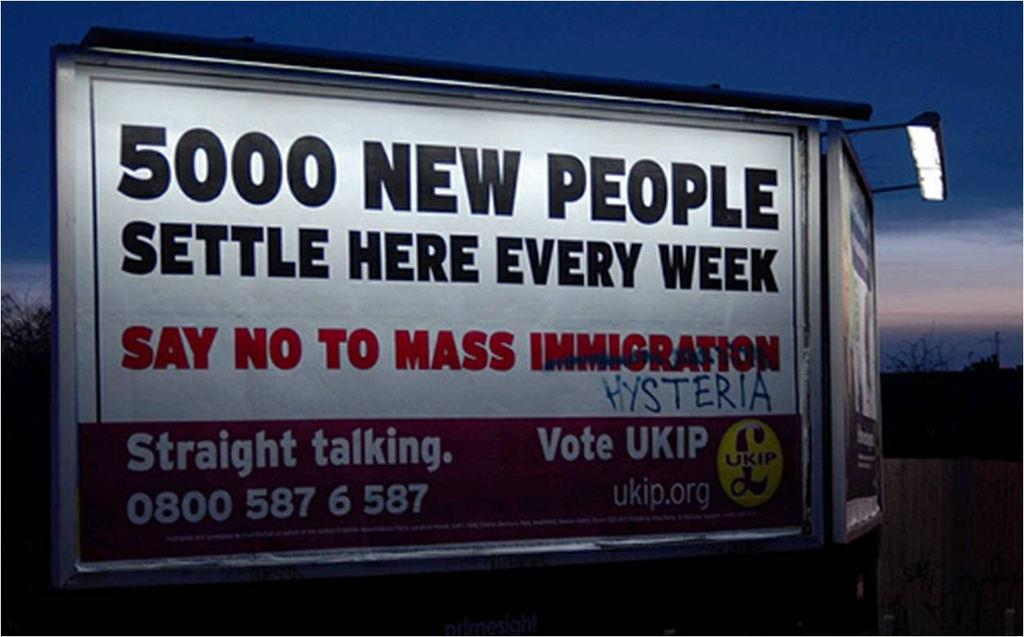<image>
Render a clear and concise summary of the photo. A billboard saying 5000 new people settle here every week. 